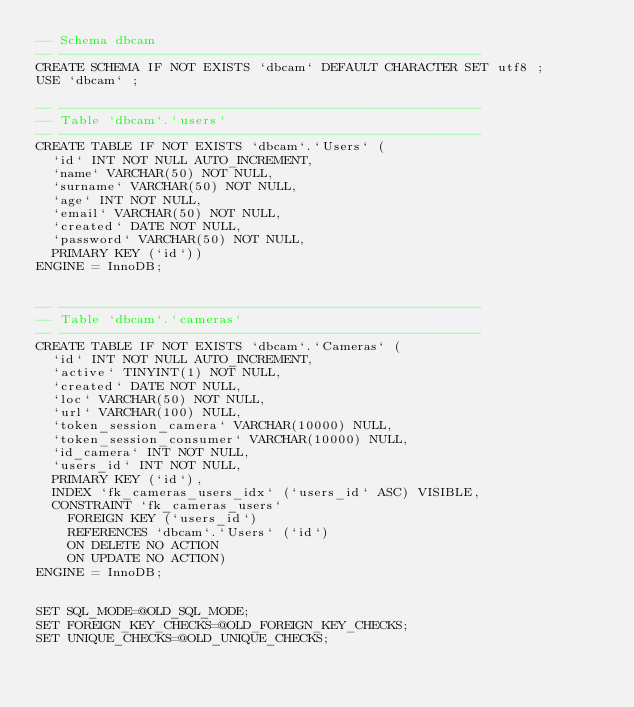Convert code to text. <code><loc_0><loc_0><loc_500><loc_500><_SQL_>-- Schema dbcam
-- -----------------------------------------------------
CREATE SCHEMA IF NOT EXISTS `dbcam` DEFAULT CHARACTER SET utf8 ;
USE `dbcam` ;

-- -----------------------------------------------------
-- Table `dbcam`.`users`
-- -----------------------------------------------------
CREATE TABLE IF NOT EXISTS `dbcam`.`Users` (
  `id` INT NOT NULL AUTO_INCREMENT,
  `name` VARCHAR(50) NOT NULL,
  `surname` VARCHAR(50) NOT NULL,
  `age` INT NOT NULL,
  `email` VARCHAR(50) NOT NULL,
  `created` DATE NOT NULL,
  `password` VARCHAR(50) NOT NULL,
  PRIMARY KEY (`id`))
ENGINE = InnoDB;


-- -----------------------------------------------------
-- Table `dbcam`.`cameras`
-- -----------------------------------------------------
CREATE TABLE IF NOT EXISTS `dbcam`.`Cameras` (
  `id` INT NOT NULL AUTO_INCREMENT,
  `active` TINYINT(1) NOT NULL,
  `created` DATE NOT NULL,
  `loc` VARCHAR(50) NOT NULL,
  `url` VARCHAR(100) NULL,
  `token_session_camera` VARCHAR(10000) NULL,
  `token_session_consumer` VARCHAR(10000) NULL,
  `id_camera` INT NOT NULL,
  `users_id` INT NOT NULL,
  PRIMARY KEY (`id`),
  INDEX `fk_cameras_users_idx` (`users_id` ASC) VISIBLE,
  CONSTRAINT `fk_cameras_users`
    FOREIGN KEY (`users_id`)
    REFERENCES `dbcam`.`Users` (`id`)
    ON DELETE NO ACTION
    ON UPDATE NO ACTION)
ENGINE = InnoDB;


SET SQL_MODE=@OLD_SQL_MODE;
SET FOREIGN_KEY_CHECKS=@OLD_FOREIGN_KEY_CHECKS;
SET UNIQUE_CHECKS=@OLD_UNIQUE_CHECKS;
</code> 